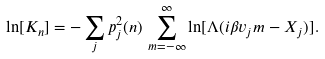<formula> <loc_0><loc_0><loc_500><loc_500>\ln [ K _ { n } ] = - \sum _ { j } p _ { j } ^ { 2 } ( { n } ) \, \sum _ { m = - \infty } ^ { \infty } \ln [ \Lambda ( i \beta v _ { j } m - X _ { j } ) ] .</formula> 